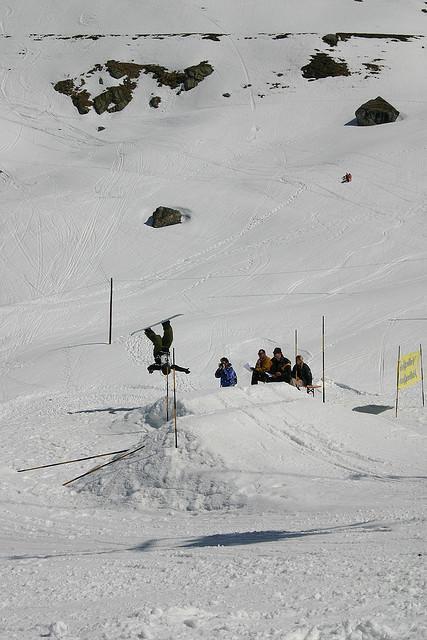How many spectators are there?
Give a very brief answer. 4. How many sheep are on the rock?
Give a very brief answer. 0. 